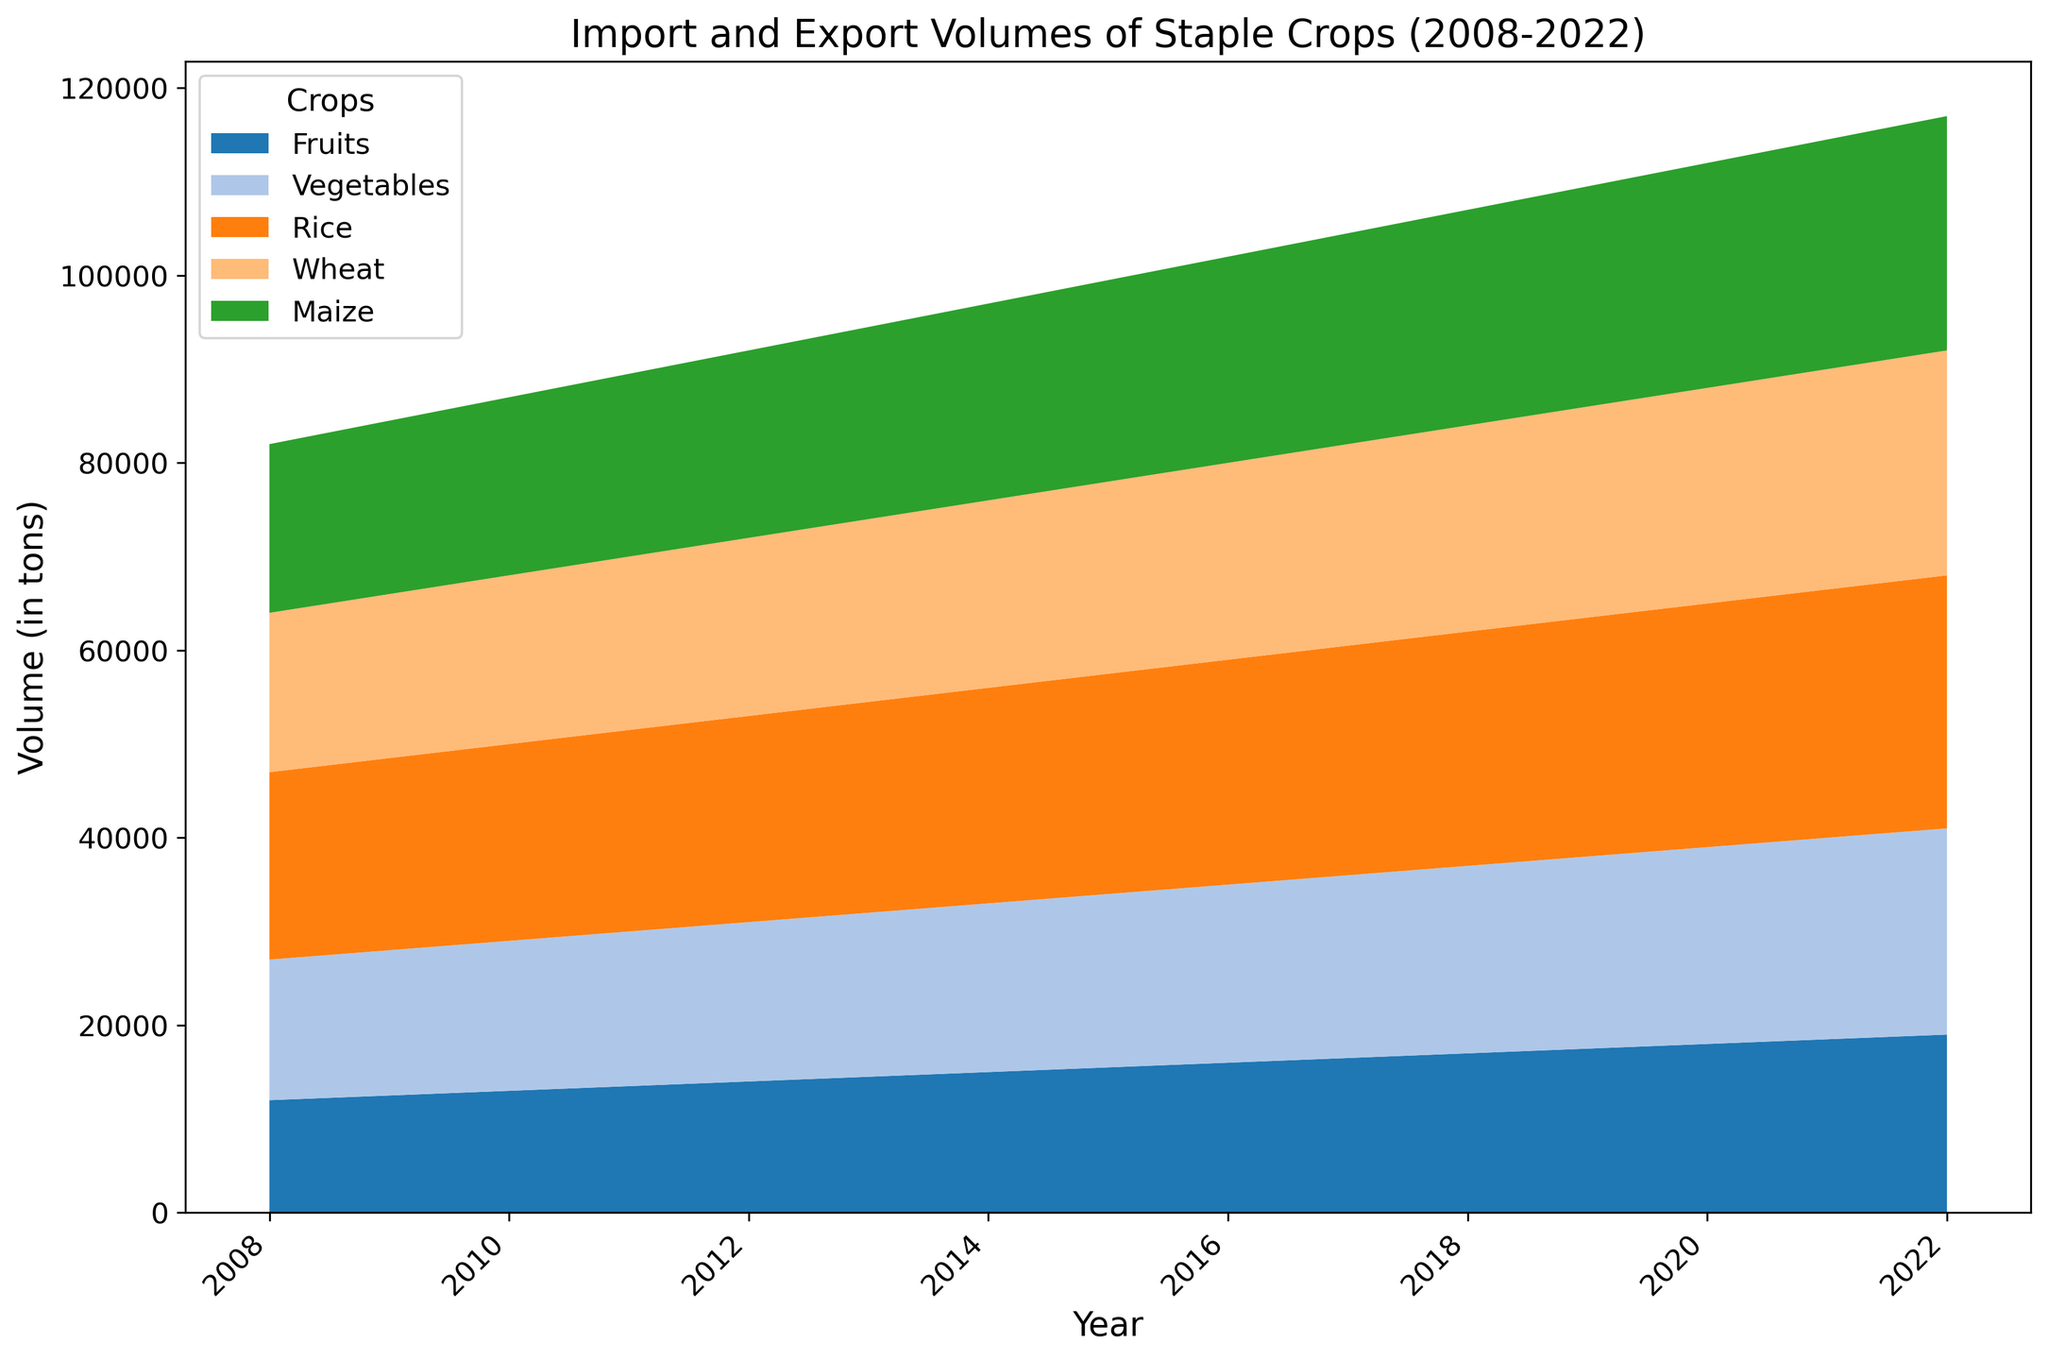How has the import volume of rice changed from 2008 to 2022? Observe the height of the area representing the rice import volumes. In 2008, the area starts at 20,000 tons and increases steadily each year, reaching 27,000 tons in 2022.
Answer: Increased Which crop had the highest import volume throughout the years? Compare the heights of the areas representing different crops. Rice consistently has the highest import volume across all years compared to others.
Answer: Rice In what year did maize exports surpass 4,000 tons? Focus on the area representing maize exports; the segment grows gradually. The export volume surpasses 4,000 tons in the year 2014.
Answer: 2014 Compare the export volumes of fruits in 2008 and 2022. Which year was higher and by how much? Look at the heights of the segments representing fruit exports for 2008 and 2022. In 2008, the export volume was 5,000 tons, while in 2022, it was 7,800 tons. The difference is 7,800 - 5,000 = 2,800 tons.
Answer: 2022 by 2,800 tons What is the average export volume of vegetables across all years? Sum the vegetable export volumes for each year (4,000 + 4,200 + 4,400 + 4,600 + 4,800 + 5,000 + 5,200 + 5,400 + 5,600 + 5,800 + 6,000 + 6,200 + 6,400 + 6,600 + 6,800) = 85,000 tons and divide by 15 years. Average is 85,000 / 15 ≈ 5,667 tons.
Answer: Approximately 5,667 tons Which year shows the greatest increase in wheat import volume compared to the previous year? Calculate the year-over-year differences for wheat import volumes and find the greatest. Differences are: 500, 500, 500, 500, 500, 500, 500, 500, 500, 500, 500, 500, 500, 500. So, the greatest increase is 500 tons occurring equally every year.
Answer: Equally every year What is the total import volume for all crops in 2021? Sum the import volumes for all crops in 2021: Fruits (18,500) + Vegetables (21,500) + Rice (26,500) + Wheat (23,500) + Maize (24,500) = 114,500 tons.
Answer: 114,500 tons Compare the export volumes of maize and vegetables in 2020. Which is higher and by how much? Look at the segments for maize and vegetables in 2020. Maize export volume is 4,700 tons and vegetables export volume is 6,400 tons. Difference is 6,400 - 4,700 = 1,700 tons.
Answer: Vegetables by 1,700 tons In which year did the export volume of rice exceed 4,000 tons for the first time? Identify the segment for rice exports and track where it first exceeds 4,000 tons. This occurs in 2018.
Answer: 2018 